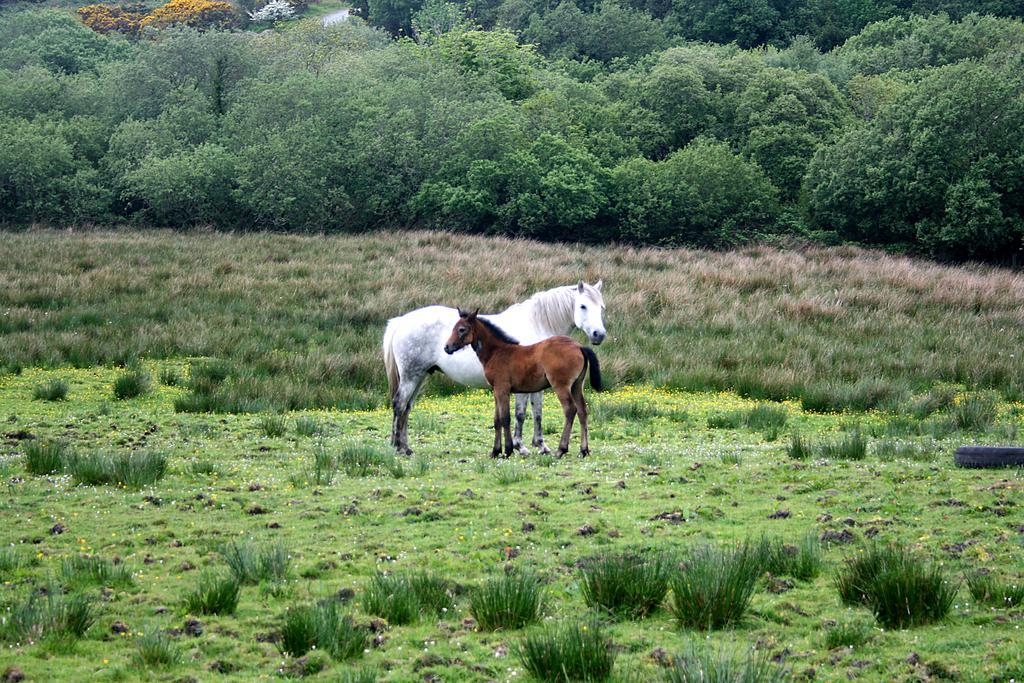How would you summarize this image in a sentence or two? In this image on a ground there is a white horse and a brown horse. On the ground there are grasses. In the background there are trees. 